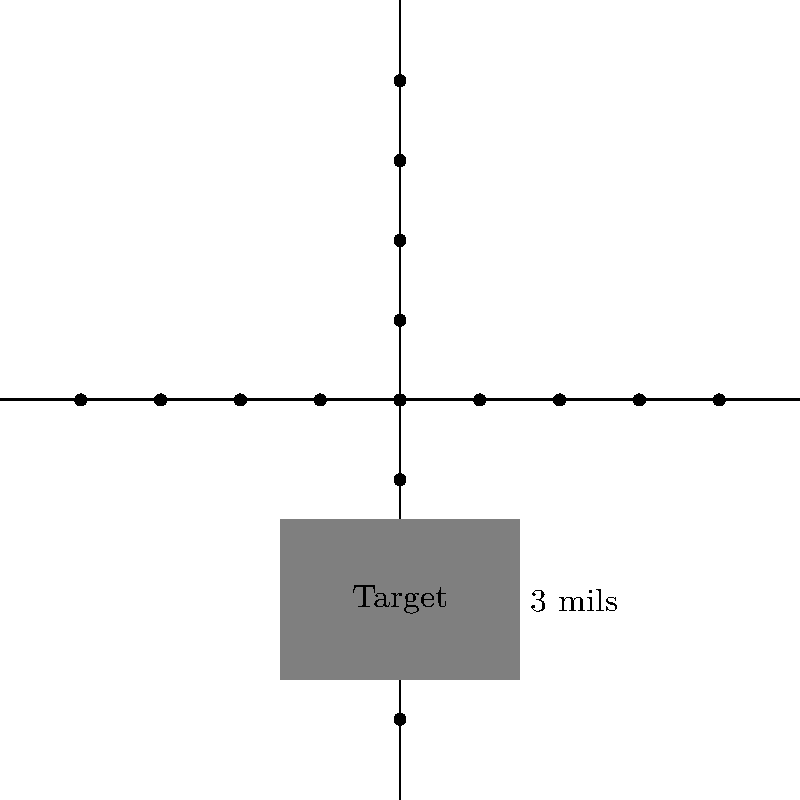You're observing a target through your scope with a mil-dot reticle. The target appears to be 3 mils tall. If you know the actual height of the target is 1.8 meters, what is the approximate distance to the target in meters? To solve this problem, we'll use the mil-dot formula:

$$ \text{Target Size (m)} = \frac{\text{Target Size (mils)} \times \text{Distance (m)}}{1000} $$

We know:
- Target Size (mils) = 3 mils
- Target Size (m) = 1.8 meters

Let's rearrange the formula to solve for Distance:

$$ \text{Distance (m)} = \frac{\text{Target Size (m)} \times 1000}{\text{Target Size (mils)}} $$

Now, let's plug in our known values:

$$ \text{Distance (m)} = \frac{1.8 \text{ m} \times 1000}{3 \text{ mils}} $$

$$ \text{Distance (m)} = \frac{1800}{3} = 600 \text{ m} $$

Therefore, the approximate distance to the target is 600 meters.
Answer: 600 meters 